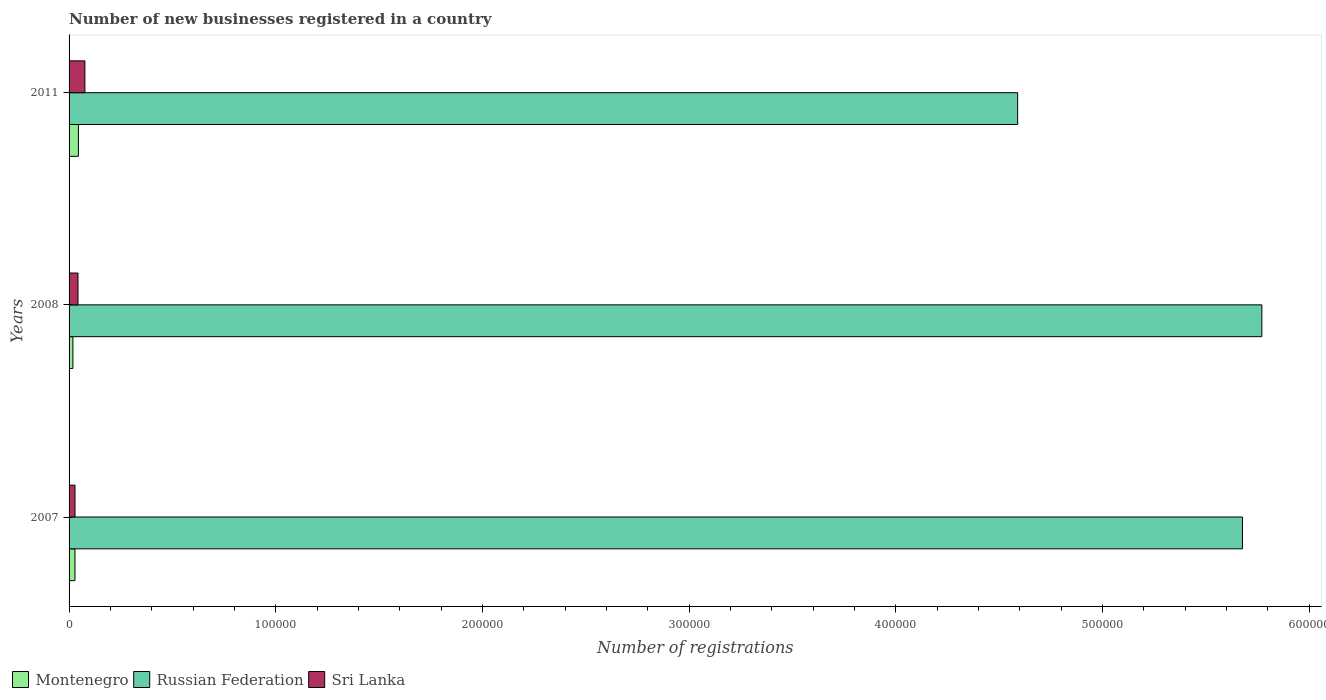Are the number of bars per tick equal to the number of legend labels?
Ensure brevity in your answer.  Yes. Are the number of bars on each tick of the Y-axis equal?
Your response must be concise. Yes. How many bars are there on the 3rd tick from the top?
Provide a succinct answer. 3. How many bars are there on the 1st tick from the bottom?
Your answer should be compact. 3. What is the label of the 2nd group of bars from the top?
Provide a short and direct response. 2008. What is the number of new businesses registered in Russian Federation in 2007?
Provide a succinct answer. 5.68e+05. Across all years, what is the maximum number of new businesses registered in Russian Federation?
Make the answer very short. 5.77e+05. Across all years, what is the minimum number of new businesses registered in Sri Lanka?
Provide a succinct answer. 2873. In which year was the number of new businesses registered in Sri Lanka maximum?
Give a very brief answer. 2011. In which year was the number of new businesses registered in Russian Federation minimum?
Offer a very short reply. 2011. What is the total number of new businesses registered in Russian Federation in the graph?
Keep it short and to the point. 1.60e+06. What is the difference between the number of new businesses registered in Montenegro in 2007 and that in 2008?
Keep it short and to the point. 1002. What is the difference between the number of new businesses registered in Sri Lanka in 2008 and the number of new businesses registered in Montenegro in 2007?
Your answer should be compact. 1473. What is the average number of new businesses registered in Russian Federation per year?
Provide a short and direct response. 5.35e+05. In the year 2007, what is the difference between the number of new businesses registered in Russian Federation and number of new businesses registered in Sri Lanka?
Offer a very short reply. 5.65e+05. In how many years, is the number of new businesses registered in Russian Federation greater than 60000 ?
Your answer should be very brief. 3. What is the ratio of the number of new businesses registered in Sri Lanka in 2007 to that in 2011?
Offer a terse response. 0.37. Is the number of new businesses registered in Montenegro in 2007 less than that in 2011?
Provide a succinct answer. Yes. Is the difference between the number of new businesses registered in Russian Federation in 2007 and 2011 greater than the difference between the number of new businesses registered in Sri Lanka in 2007 and 2011?
Provide a short and direct response. Yes. What is the difference between the highest and the second highest number of new businesses registered in Russian Federation?
Make the answer very short. 9377. What is the difference between the highest and the lowest number of new businesses registered in Russian Federation?
Offer a terse response. 1.18e+05. In how many years, is the number of new businesses registered in Montenegro greater than the average number of new businesses registered in Montenegro taken over all years?
Your answer should be compact. 1. What does the 3rd bar from the top in 2008 represents?
Provide a short and direct response. Montenegro. What does the 1st bar from the bottom in 2008 represents?
Give a very brief answer. Montenegro. Is it the case that in every year, the sum of the number of new businesses registered in Montenegro and number of new businesses registered in Russian Federation is greater than the number of new businesses registered in Sri Lanka?
Offer a terse response. Yes. How many years are there in the graph?
Your answer should be compact. 3. Where does the legend appear in the graph?
Offer a very short reply. Bottom left. What is the title of the graph?
Offer a very short reply. Number of new businesses registered in a country. Does "Singapore" appear as one of the legend labels in the graph?
Your response must be concise. No. What is the label or title of the X-axis?
Provide a short and direct response. Number of registrations. What is the Number of registrations in Montenegro in 2007?
Your response must be concise. 2848. What is the Number of registrations of Russian Federation in 2007?
Offer a very short reply. 5.68e+05. What is the Number of registrations in Sri Lanka in 2007?
Your response must be concise. 2873. What is the Number of registrations in Montenegro in 2008?
Make the answer very short. 1846. What is the Number of registrations of Russian Federation in 2008?
Your answer should be compact. 5.77e+05. What is the Number of registrations of Sri Lanka in 2008?
Keep it short and to the point. 4321. What is the Number of registrations of Montenegro in 2011?
Give a very brief answer. 4513. What is the Number of registrations in Russian Federation in 2011?
Provide a short and direct response. 4.59e+05. What is the Number of registrations of Sri Lanka in 2011?
Provide a succinct answer. 7662. Across all years, what is the maximum Number of registrations in Montenegro?
Offer a very short reply. 4513. Across all years, what is the maximum Number of registrations in Russian Federation?
Keep it short and to the point. 5.77e+05. Across all years, what is the maximum Number of registrations in Sri Lanka?
Provide a succinct answer. 7662. Across all years, what is the minimum Number of registrations in Montenegro?
Offer a terse response. 1846. Across all years, what is the minimum Number of registrations in Russian Federation?
Offer a very short reply. 4.59e+05. Across all years, what is the minimum Number of registrations in Sri Lanka?
Give a very brief answer. 2873. What is the total Number of registrations of Montenegro in the graph?
Give a very brief answer. 9207. What is the total Number of registrations of Russian Federation in the graph?
Keep it short and to the point. 1.60e+06. What is the total Number of registrations of Sri Lanka in the graph?
Ensure brevity in your answer.  1.49e+04. What is the difference between the Number of registrations in Montenegro in 2007 and that in 2008?
Give a very brief answer. 1002. What is the difference between the Number of registrations in Russian Federation in 2007 and that in 2008?
Provide a short and direct response. -9377. What is the difference between the Number of registrations in Sri Lanka in 2007 and that in 2008?
Ensure brevity in your answer.  -1448. What is the difference between the Number of registrations in Montenegro in 2007 and that in 2011?
Provide a succinct answer. -1665. What is the difference between the Number of registrations in Russian Federation in 2007 and that in 2011?
Give a very brief answer. 1.09e+05. What is the difference between the Number of registrations in Sri Lanka in 2007 and that in 2011?
Provide a succinct answer. -4789. What is the difference between the Number of registrations in Montenegro in 2008 and that in 2011?
Ensure brevity in your answer.  -2667. What is the difference between the Number of registrations in Russian Federation in 2008 and that in 2011?
Ensure brevity in your answer.  1.18e+05. What is the difference between the Number of registrations in Sri Lanka in 2008 and that in 2011?
Keep it short and to the point. -3341. What is the difference between the Number of registrations in Montenegro in 2007 and the Number of registrations in Russian Federation in 2008?
Offer a terse response. -5.74e+05. What is the difference between the Number of registrations in Montenegro in 2007 and the Number of registrations in Sri Lanka in 2008?
Your answer should be compact. -1473. What is the difference between the Number of registrations in Russian Federation in 2007 and the Number of registrations in Sri Lanka in 2008?
Offer a terse response. 5.63e+05. What is the difference between the Number of registrations in Montenegro in 2007 and the Number of registrations in Russian Federation in 2011?
Give a very brief answer. -4.56e+05. What is the difference between the Number of registrations in Montenegro in 2007 and the Number of registrations in Sri Lanka in 2011?
Ensure brevity in your answer.  -4814. What is the difference between the Number of registrations of Russian Federation in 2007 and the Number of registrations of Sri Lanka in 2011?
Keep it short and to the point. 5.60e+05. What is the difference between the Number of registrations in Montenegro in 2008 and the Number of registrations in Russian Federation in 2011?
Provide a short and direct response. -4.57e+05. What is the difference between the Number of registrations in Montenegro in 2008 and the Number of registrations in Sri Lanka in 2011?
Your answer should be very brief. -5816. What is the difference between the Number of registrations of Russian Federation in 2008 and the Number of registrations of Sri Lanka in 2011?
Ensure brevity in your answer.  5.69e+05. What is the average Number of registrations of Montenegro per year?
Your answer should be very brief. 3069. What is the average Number of registrations of Russian Federation per year?
Offer a terse response. 5.35e+05. What is the average Number of registrations in Sri Lanka per year?
Ensure brevity in your answer.  4952. In the year 2007, what is the difference between the Number of registrations in Montenegro and Number of registrations in Russian Federation?
Offer a terse response. -5.65e+05. In the year 2007, what is the difference between the Number of registrations of Russian Federation and Number of registrations of Sri Lanka?
Provide a succinct answer. 5.65e+05. In the year 2008, what is the difference between the Number of registrations in Montenegro and Number of registrations in Russian Federation?
Your answer should be compact. -5.75e+05. In the year 2008, what is the difference between the Number of registrations of Montenegro and Number of registrations of Sri Lanka?
Offer a terse response. -2475. In the year 2008, what is the difference between the Number of registrations of Russian Federation and Number of registrations of Sri Lanka?
Your response must be concise. 5.73e+05. In the year 2011, what is the difference between the Number of registrations in Montenegro and Number of registrations in Russian Federation?
Make the answer very short. -4.54e+05. In the year 2011, what is the difference between the Number of registrations of Montenegro and Number of registrations of Sri Lanka?
Your response must be concise. -3149. In the year 2011, what is the difference between the Number of registrations in Russian Federation and Number of registrations in Sri Lanka?
Make the answer very short. 4.51e+05. What is the ratio of the Number of registrations in Montenegro in 2007 to that in 2008?
Make the answer very short. 1.54. What is the ratio of the Number of registrations in Russian Federation in 2007 to that in 2008?
Provide a succinct answer. 0.98. What is the ratio of the Number of registrations in Sri Lanka in 2007 to that in 2008?
Provide a succinct answer. 0.66. What is the ratio of the Number of registrations in Montenegro in 2007 to that in 2011?
Keep it short and to the point. 0.63. What is the ratio of the Number of registrations of Russian Federation in 2007 to that in 2011?
Provide a short and direct response. 1.24. What is the ratio of the Number of registrations of Montenegro in 2008 to that in 2011?
Your answer should be very brief. 0.41. What is the ratio of the Number of registrations of Russian Federation in 2008 to that in 2011?
Offer a terse response. 1.26. What is the ratio of the Number of registrations in Sri Lanka in 2008 to that in 2011?
Your response must be concise. 0.56. What is the difference between the highest and the second highest Number of registrations in Montenegro?
Your answer should be compact. 1665. What is the difference between the highest and the second highest Number of registrations of Russian Federation?
Provide a succinct answer. 9377. What is the difference between the highest and the second highest Number of registrations of Sri Lanka?
Your answer should be compact. 3341. What is the difference between the highest and the lowest Number of registrations of Montenegro?
Provide a succinct answer. 2667. What is the difference between the highest and the lowest Number of registrations of Russian Federation?
Provide a succinct answer. 1.18e+05. What is the difference between the highest and the lowest Number of registrations in Sri Lanka?
Ensure brevity in your answer.  4789. 